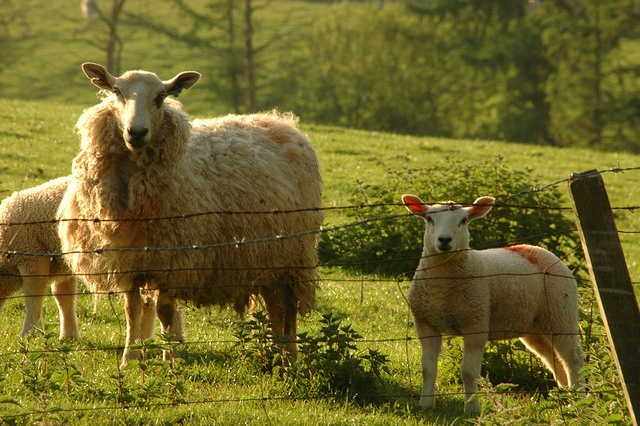Describe the objects in this image and their specific colors. I can see sheep in olive, maroon, black, and gray tones, sheep in olive, black, and gray tones, and sheep in olive, maroon, and black tones in this image. 